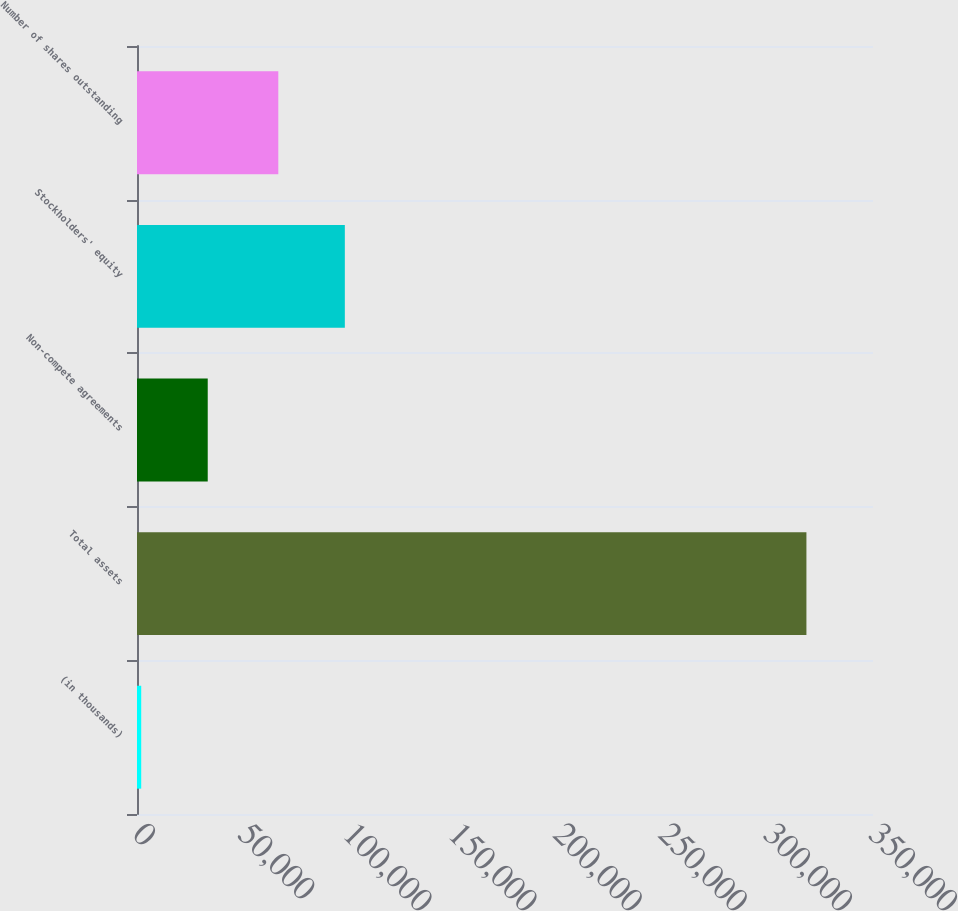Convert chart. <chart><loc_0><loc_0><loc_500><loc_500><bar_chart><fcel>(in thousands)<fcel>Total assets<fcel>Non-compete agreements<fcel>Stockholders' equity<fcel>Number of shares outstanding<nl><fcel>2002<fcel>318338<fcel>33635.6<fcel>98832.6<fcel>67199<nl></chart> 